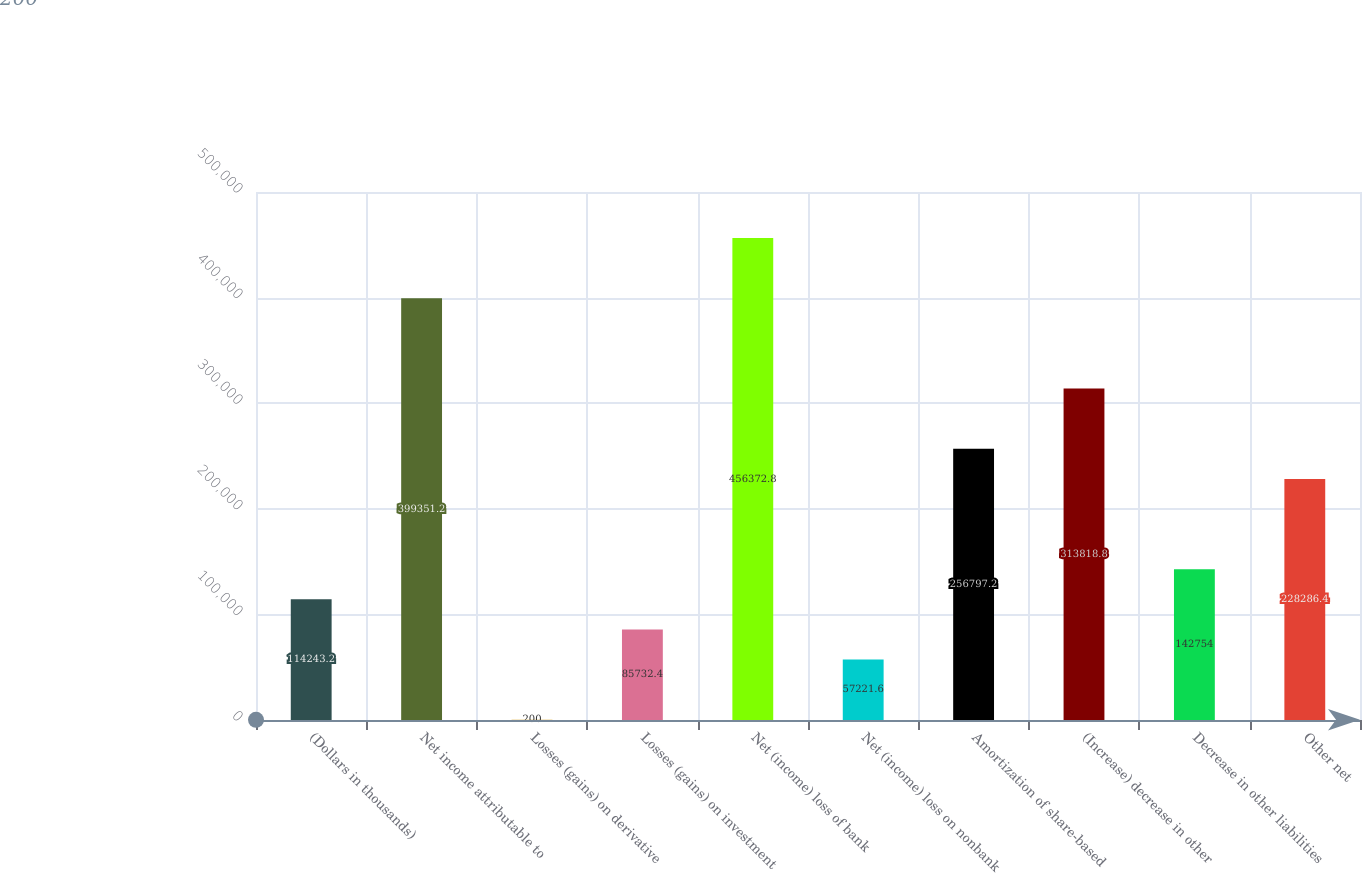Convert chart. <chart><loc_0><loc_0><loc_500><loc_500><bar_chart><fcel>(Dollars in thousands)<fcel>Net income attributable to<fcel>Losses (gains) on derivative<fcel>Losses (gains) on investment<fcel>Net (income) loss of bank<fcel>Net (income) loss on nonbank<fcel>Amortization of share-based<fcel>(Increase) decrease in other<fcel>Decrease in other liabilities<fcel>Other net<nl><fcel>114243<fcel>399351<fcel>200<fcel>85732.4<fcel>456373<fcel>57221.6<fcel>256797<fcel>313819<fcel>142754<fcel>228286<nl></chart> 